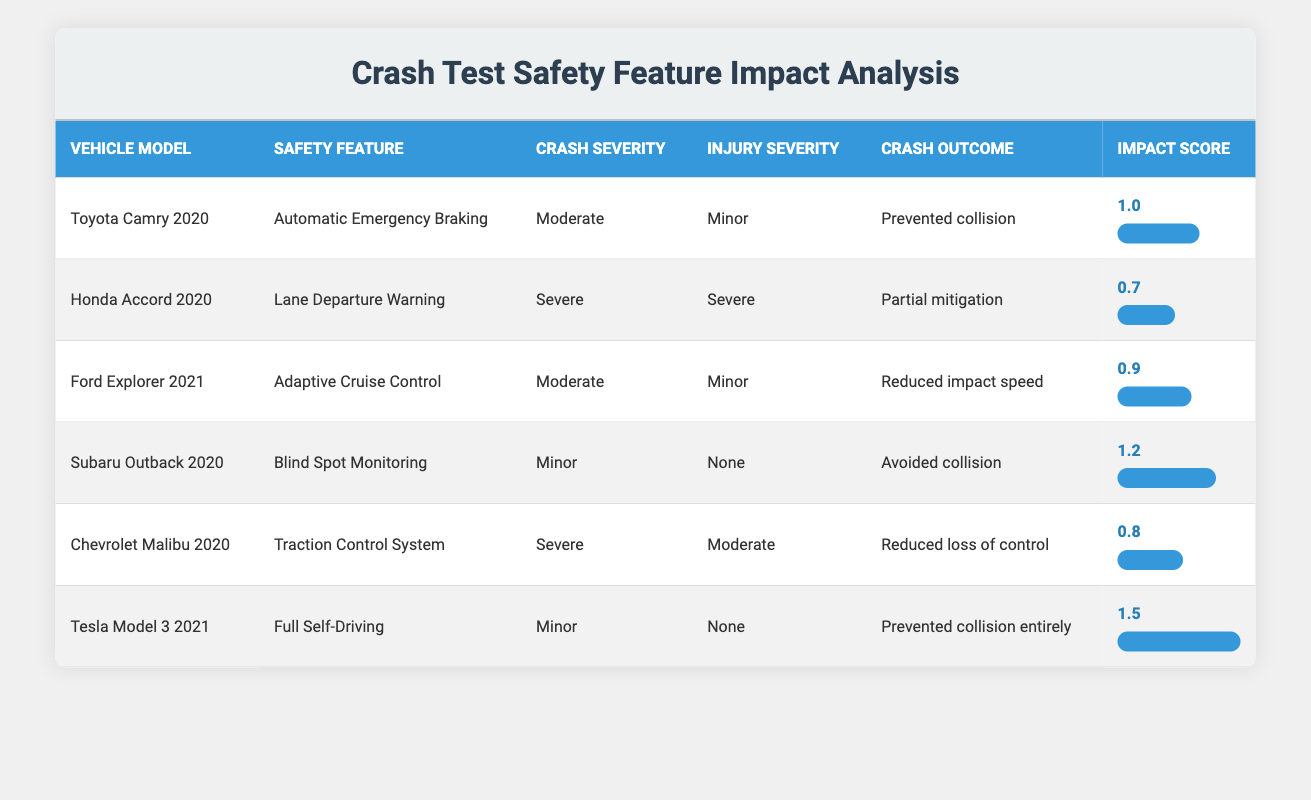What is the highest impact score recorded in the table? The highest impact score can be identified by checking the values in the "Impact Score" column. In the table, the highest value is 1.5, which corresponds to the Tesla Model 3 2021 with the "Full Self-Driving" safety feature.
Answer: 1.5 Which vehicle model had the outcome of preventing a collision entirely? Referring to the "Crash Outcome" column, the Tesla Model 3 2021 is the only vehicle that mentions preventing a collision entirely. This information is derived directly from the relevant row in the table.
Answer: Tesla Model 3 2021 What is the average impact score of all listed vehicles? To find the average, first sum the impact scores: 1.0 + 0.7 + 0.9 + 1.2 + 0.8 + 1.5 = 6.1. Then, divide by the number of vehicles, which is 6. Thus, the average impact score is 6.1 / 6 = 1.01667, approximately 1.02 when rounded to two decimal points.
Answer: 1.02 Did any vehicle model have a minor injury severity with a moderate crash severity? By examining the table, the Ford Explorer 2021 meets this criterion as it has both moderate crash severity and minor injury severity. This conclusion is derived from the specific data points listed.
Answer: Yes Which safety feature had the lowest impact score, and what was the crash outcome associated with it? The safety feature with the lowest impact score is "Lane Departure Warning," associated with the Honda Accord 2020, which has a crash outcome of "Partial mitigation." This data comparison involves reviewing the impact scores for each safety feature.
Answer: Lane Departure Warning; Partial mitigation 